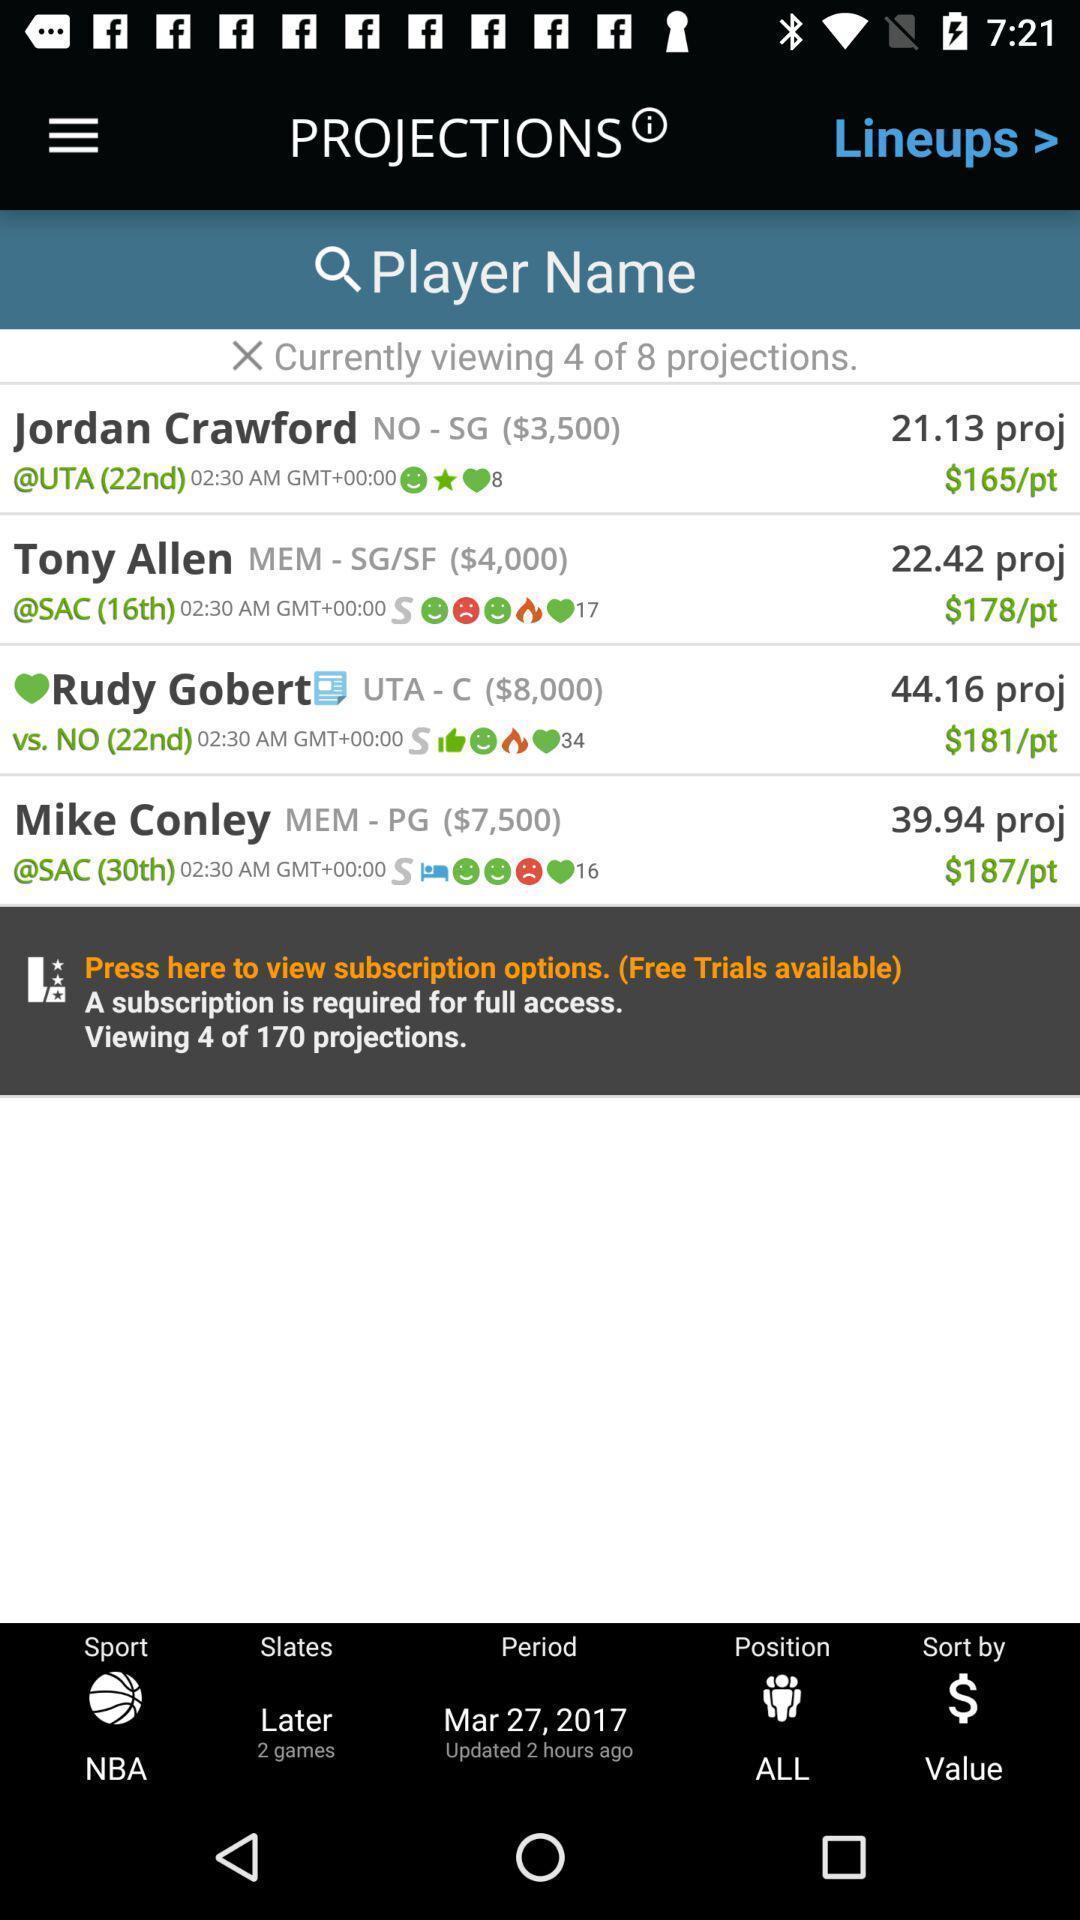Give me a narrative description of this picture. Screen shows list of names in a sports app. 